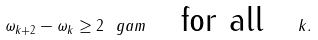<formula> <loc_0><loc_0><loc_500><loc_500>\omega _ { k + 2 } - \omega _ { k } \geq 2 \ g a m \quad \text {for all} \quad k .</formula> 